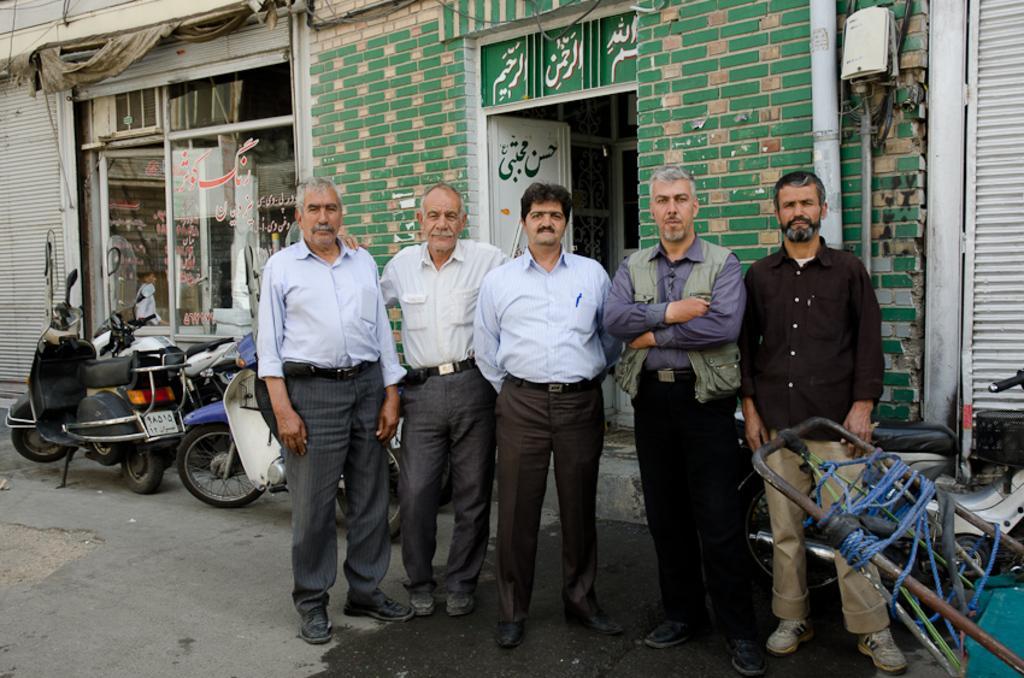Please provide a concise description of this image. At the bottom of the image there is a road. In the middle of the road there are five men standing. Behind them there is a green color brick wall with a room and a door and also there is a pipe and white box on it. Beside the wall to the left side there is a store with glass door. In front of the stores there are few vehicles on the road. At the right corner of the image there is a white shutter. In front of the shutter there is a vehicle and at the right bottom corner of the image there is a machine. 